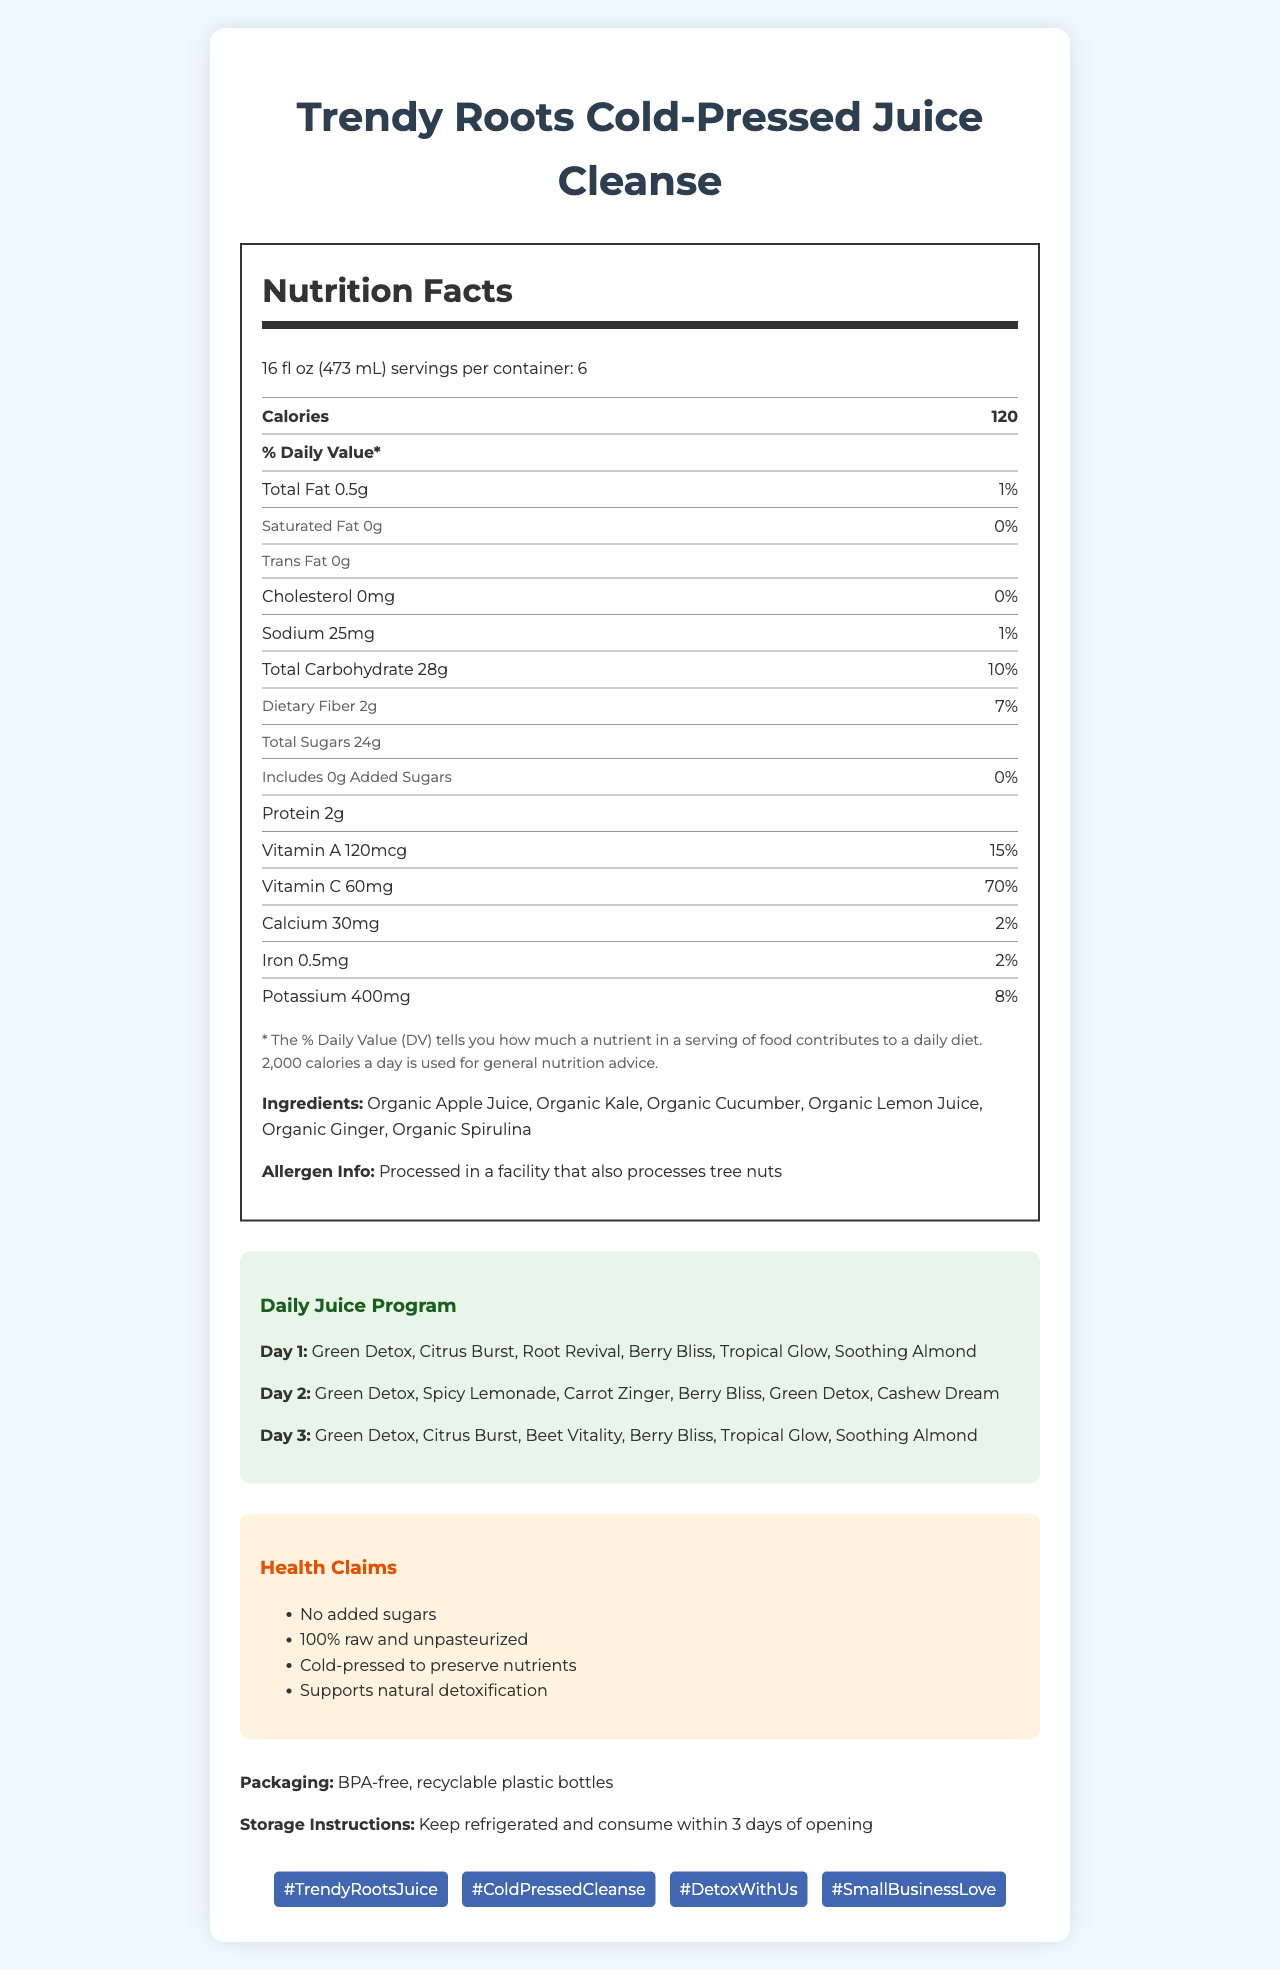what is the serving size for Trendy Roots Cold-Pressed Juice Cleanse? The serving size is listed at the top of the Nutrition Facts section and reads "16 fl oz (473 mL)".
Answer: 16 fl oz (473 mL) what are the total calories per serving? The total calories per serving are written clearly in the Calories section of the Nutrition Facts.
Answer: 120 how much Total Fat is in one serving? The amount of Total Fat per serving is shown in the Nutrition Facts and it is 0.5g.
Answer: 0.5g how much is the Daily Value (%) for Vitamin C in one serving? The Daily Value for Vitamin C is displayed on the Nutrition Facts label and is 70%.
Answer: 70% which juice is not included on Day 2 of the daily juice program? A. Soothing Almond B. Citrus Burst C. Cashew Dream D. Tropical Glow On Day 2, the juices listed are Green Detox, Spicy Lemonade, Carrot Zinger, Berry Bliss, Green Detox, and Cashew Dream. Citrus Burst is not included on Day 2.
Answer: B what dietary fiber content is in one serving? The dietary fiber content per serving is shown in the Nutrition Facts and it is 2g.
Answer: 2g what are the health claims associated with this juice cleanse program? A. No added sugars B. 100% raw and unpasteurized C. Cold-pressed to preserve nutrients D. Supports natural detoxification E. All of the above The health claims section lists "No added sugars", "100% raw and unpasteurized", "Cold-pressed to preserve nutrients", and "Supports natural detoxification".
Answer: E is this product processed in a facility that also processes tree nuts? The allergen information clearly states that the product is processed in a facility that also processes tree nuts.
Answer: Yes describe the main idea of the document. The document is detailed with various sections including nutrition information, a daily program, health benefits, and additional relevant labels such as packaging and social media promotion, aiming to inform consumers fully about the juice cleanse program.
Answer: The document provides comprehensive nutritional and other relevant details about the Trendy Roots Cold-Pressed Juice Cleanse. It includes a detailed Nutrition Facts Label, ingredients, allergen information, daily juice program, health claims, packaging, storage instructions, and social media hashtags. what is the potassium content in one serving? The potassium content per serving is displayed in the Nutrition Facts section and it is 400mg.
Answer: 400mg how many servings are there per container? The servings per container are listed in the nutrition facts and it states there are 6 servings per container.
Answer: 6 how many grams of added sugars are in one serving? The amount of added sugars per serving is listed as 0g in the Nutrition Facts.
Answer: 0g what is the recommended storage instruction? The storage instructions specify to keep the product refrigerated and to consume it within 3 days of opening.
Answer: Keep refrigerated and consume within 3 days of opening what type of packaging is used? The packaging section mentions that the product comes in BPA-free, recyclable plastic bottles.
Answer: BPA-free, recyclable plastic bottles what is the Instagram hashtag associated with this juice cleanse program? The hashtags are listed at the end of the document and include #TrendyRootsJuice, #ColdPressedCleanse, #DetoxWithUs, and #SmallBusinessLove.
Answer: #TrendyRootsJuice, #ColdPressedCleanse, #DetoxWithUs, #SmallBusinessLove how much iron is in one serving? The amount of iron per serving is shown in the Nutrition Facts and it is 0.5mg.
Answer: 0.5mg without opening the bottle, how long can the juices be stored? The document provides storage instructions only for once the bottle has been opened (consume within 3 days of opening). It does not specify the storage duration if unopened.
Answer: Cannot be determined 